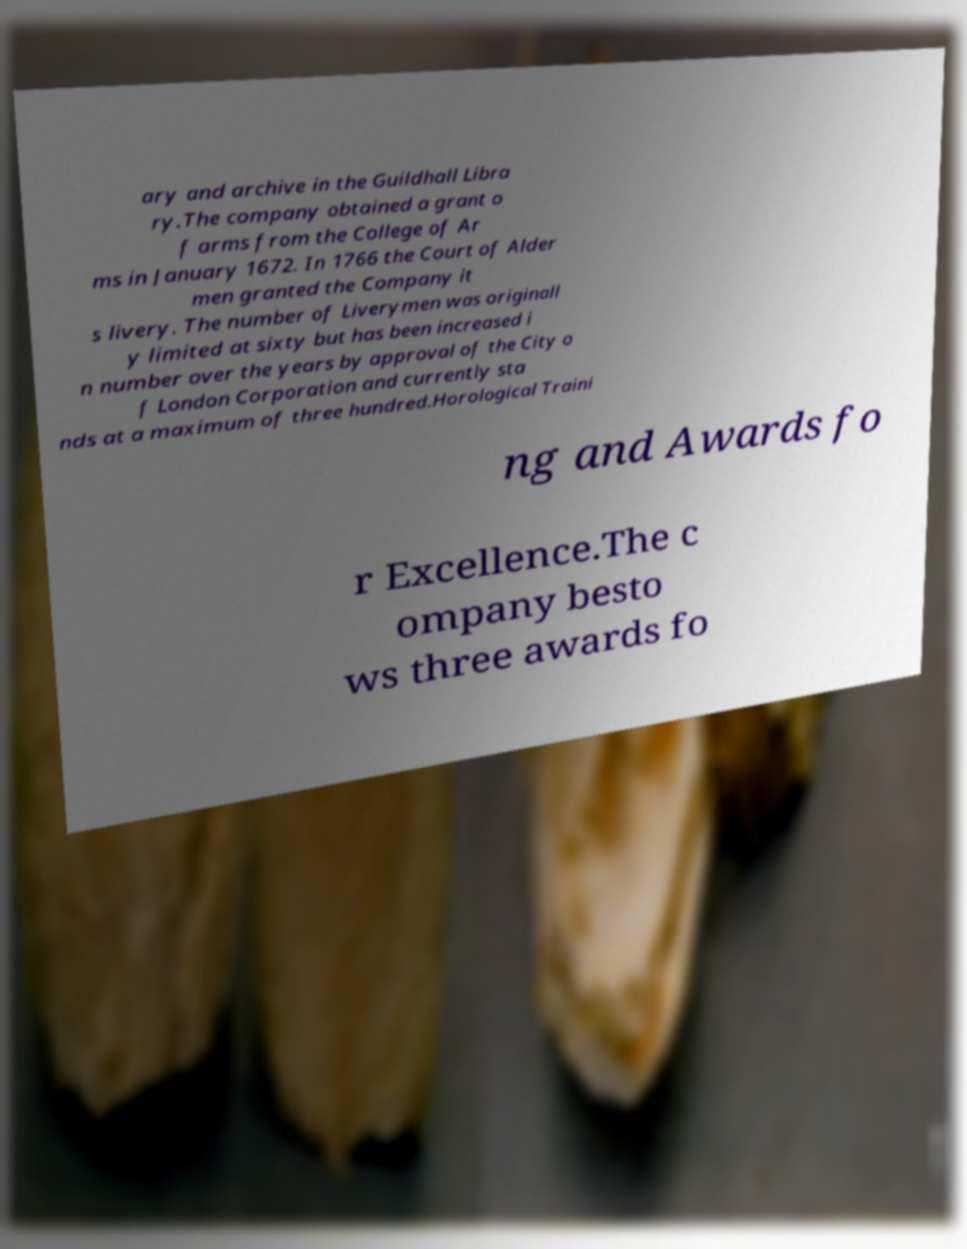There's text embedded in this image that I need extracted. Can you transcribe it verbatim? ary and archive in the Guildhall Libra ry.The company obtained a grant o f arms from the College of Ar ms in January 1672. In 1766 the Court of Alder men granted the Company it s livery. The number of Liverymen was originall y limited at sixty but has been increased i n number over the years by approval of the City o f London Corporation and currently sta nds at a maximum of three hundred.Horological Traini ng and Awards fo r Excellence.The c ompany besto ws three awards fo 